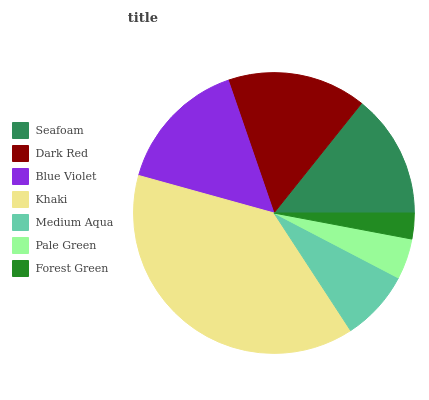Is Forest Green the minimum?
Answer yes or no. Yes. Is Khaki the maximum?
Answer yes or no. Yes. Is Dark Red the minimum?
Answer yes or no. No. Is Dark Red the maximum?
Answer yes or no. No. Is Dark Red greater than Seafoam?
Answer yes or no. Yes. Is Seafoam less than Dark Red?
Answer yes or no. Yes. Is Seafoam greater than Dark Red?
Answer yes or no. No. Is Dark Red less than Seafoam?
Answer yes or no. No. Is Seafoam the high median?
Answer yes or no. Yes. Is Seafoam the low median?
Answer yes or no. Yes. Is Pale Green the high median?
Answer yes or no. No. Is Blue Violet the low median?
Answer yes or no. No. 